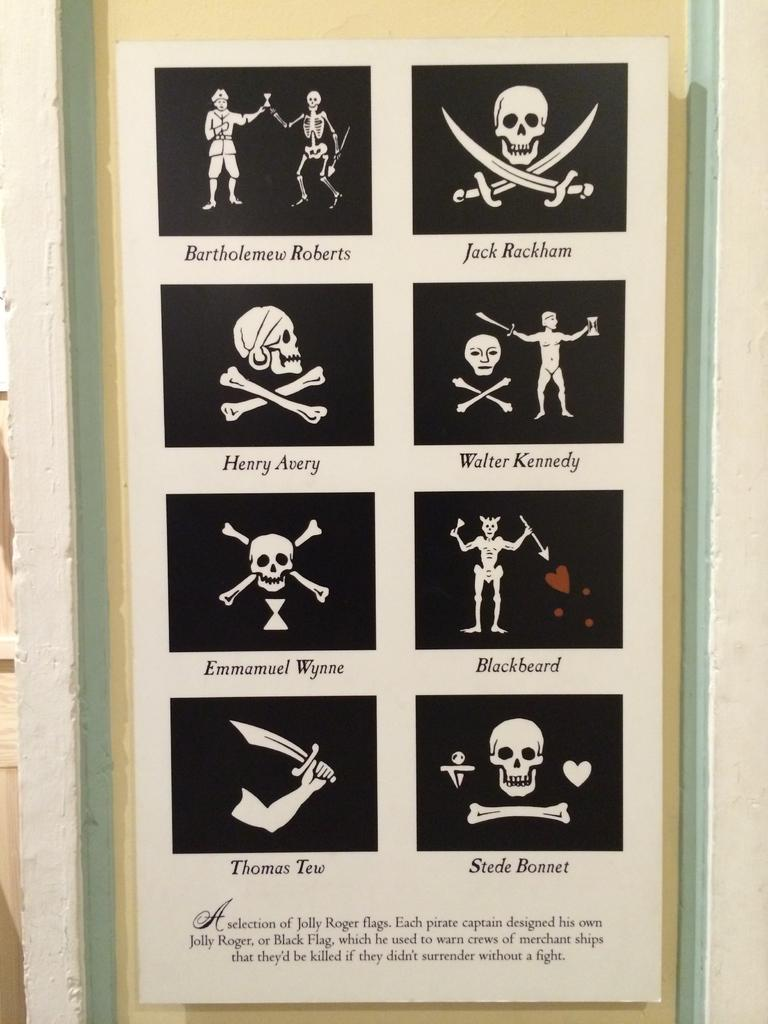What object in the image contains images of skulls? The photo frame in the image contains skull images. What else can be seen on the wall in the image? There is text on the wall in the image. How many trees are visible in the image? There are no trees visible in the image. What type of vest is the person wearing in the image? There is no person or vest present in the image. 